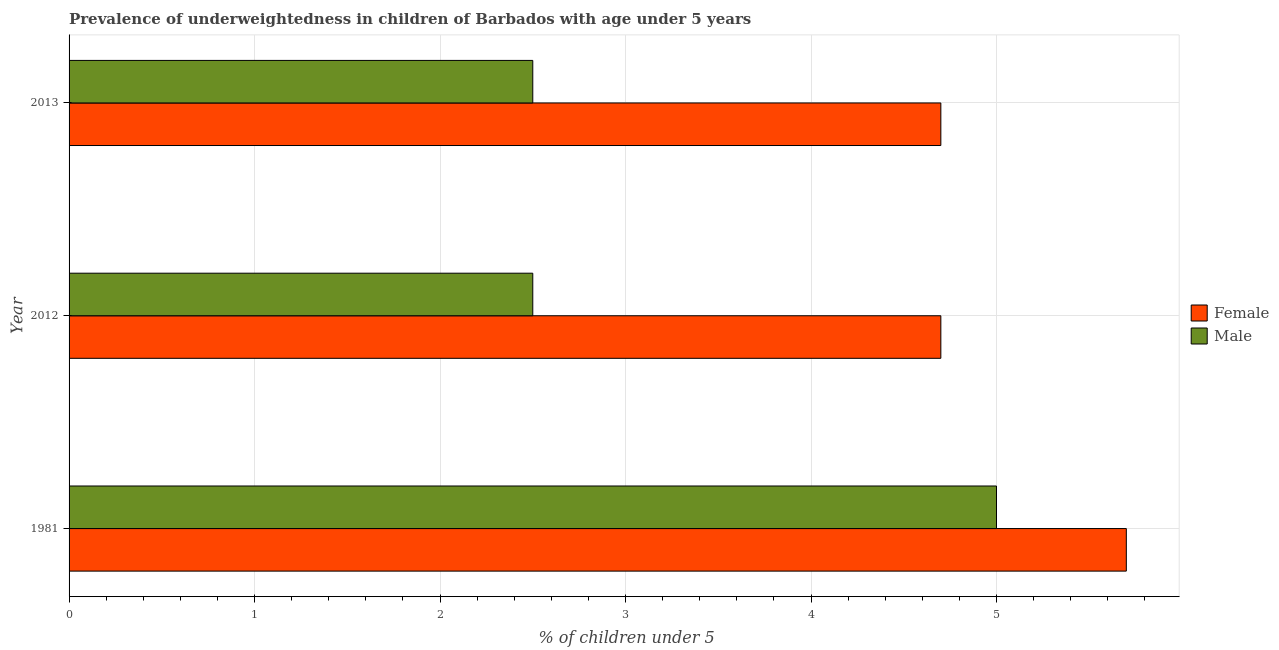Are the number of bars per tick equal to the number of legend labels?
Make the answer very short. Yes. How many bars are there on the 3rd tick from the top?
Offer a terse response. 2. In how many cases, is the number of bars for a given year not equal to the number of legend labels?
Give a very brief answer. 0. What is the percentage of underweighted male children in 2012?
Give a very brief answer. 2.5. Across all years, what is the minimum percentage of underweighted female children?
Provide a succinct answer. 4.7. In which year was the percentage of underweighted male children maximum?
Make the answer very short. 1981. In which year was the percentage of underweighted female children minimum?
Offer a terse response. 2012. What is the total percentage of underweighted female children in the graph?
Your response must be concise. 15.1. What is the difference between the percentage of underweighted female children in 1981 and the percentage of underweighted male children in 2012?
Your answer should be very brief. 3.2. What is the average percentage of underweighted female children per year?
Offer a terse response. 5.03. What is the ratio of the percentage of underweighted male children in 2012 to that in 2013?
Give a very brief answer. 1. Is the percentage of underweighted male children in 1981 less than that in 2013?
Give a very brief answer. No. What is the difference between the highest and the second highest percentage of underweighted female children?
Offer a very short reply. 1. What is the difference between the highest and the lowest percentage of underweighted male children?
Offer a very short reply. 2.5. Is the sum of the percentage of underweighted male children in 2012 and 2013 greater than the maximum percentage of underweighted female children across all years?
Offer a very short reply. No. What does the 1st bar from the top in 2013 represents?
Provide a short and direct response. Male. How many bars are there?
Offer a very short reply. 6. How many years are there in the graph?
Provide a short and direct response. 3. What is the difference between two consecutive major ticks on the X-axis?
Offer a very short reply. 1. Are the values on the major ticks of X-axis written in scientific E-notation?
Make the answer very short. No. Where does the legend appear in the graph?
Keep it short and to the point. Center right. How many legend labels are there?
Keep it short and to the point. 2. What is the title of the graph?
Make the answer very short. Prevalence of underweightedness in children of Barbados with age under 5 years. Does "Investment" appear as one of the legend labels in the graph?
Offer a very short reply. No. What is the label or title of the X-axis?
Keep it short and to the point.  % of children under 5. What is the  % of children under 5 in Female in 1981?
Provide a short and direct response. 5.7. What is the  % of children under 5 in Female in 2012?
Keep it short and to the point. 4.7. What is the  % of children under 5 of Male in 2012?
Make the answer very short. 2.5. What is the  % of children under 5 in Female in 2013?
Give a very brief answer. 4.7. What is the  % of children under 5 in Male in 2013?
Ensure brevity in your answer.  2.5. Across all years, what is the maximum  % of children under 5 in Female?
Provide a succinct answer. 5.7. Across all years, what is the maximum  % of children under 5 of Male?
Offer a very short reply. 5. Across all years, what is the minimum  % of children under 5 of Female?
Offer a terse response. 4.7. Across all years, what is the minimum  % of children under 5 of Male?
Provide a short and direct response. 2.5. What is the total  % of children under 5 of Male in the graph?
Offer a terse response. 10. What is the difference between the  % of children under 5 in Female in 1981 and that in 2012?
Make the answer very short. 1. What is the difference between the  % of children under 5 of Male in 1981 and that in 2012?
Your response must be concise. 2.5. What is the difference between the  % of children under 5 in Female in 2012 and that in 2013?
Your answer should be compact. -0. What is the difference between the  % of children under 5 in Male in 2012 and that in 2013?
Provide a succinct answer. 0. What is the difference between the  % of children under 5 in Female in 1981 and the  % of children under 5 in Male in 2012?
Your answer should be compact. 3.2. What is the average  % of children under 5 in Female per year?
Your answer should be compact. 5.03. What is the average  % of children under 5 of Male per year?
Keep it short and to the point. 3.33. In the year 2013, what is the difference between the  % of children under 5 in Female and  % of children under 5 in Male?
Provide a short and direct response. 2.2. What is the ratio of the  % of children under 5 of Female in 1981 to that in 2012?
Ensure brevity in your answer.  1.21. What is the ratio of the  % of children under 5 of Male in 1981 to that in 2012?
Ensure brevity in your answer.  2. What is the ratio of the  % of children under 5 in Female in 1981 to that in 2013?
Offer a terse response. 1.21. What is the ratio of the  % of children under 5 in Male in 1981 to that in 2013?
Make the answer very short. 2. What is the ratio of the  % of children under 5 of Female in 2012 to that in 2013?
Your answer should be very brief. 1. What is the difference between the highest and the second highest  % of children under 5 of Female?
Provide a short and direct response. 1. What is the difference between the highest and the second highest  % of children under 5 in Male?
Your answer should be compact. 2.5. What is the difference between the highest and the lowest  % of children under 5 in Female?
Provide a short and direct response. 1. 